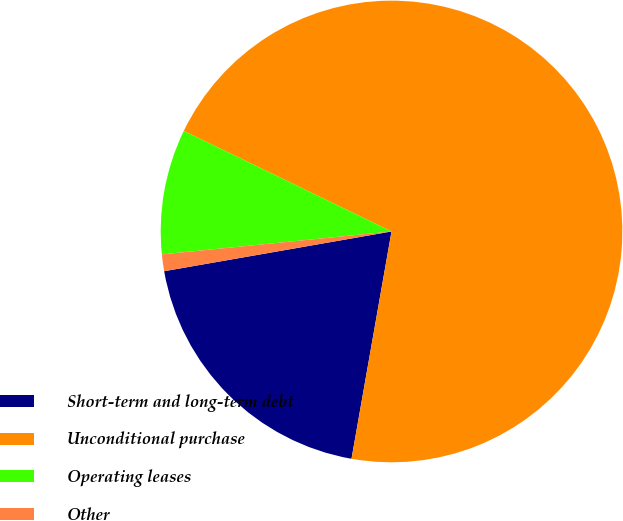<chart> <loc_0><loc_0><loc_500><loc_500><pie_chart><fcel>Short-term and long-term debt<fcel>Unconditional purchase<fcel>Operating leases<fcel>Other<nl><fcel>19.47%<fcel>70.59%<fcel>8.76%<fcel>1.17%<nl></chart> 